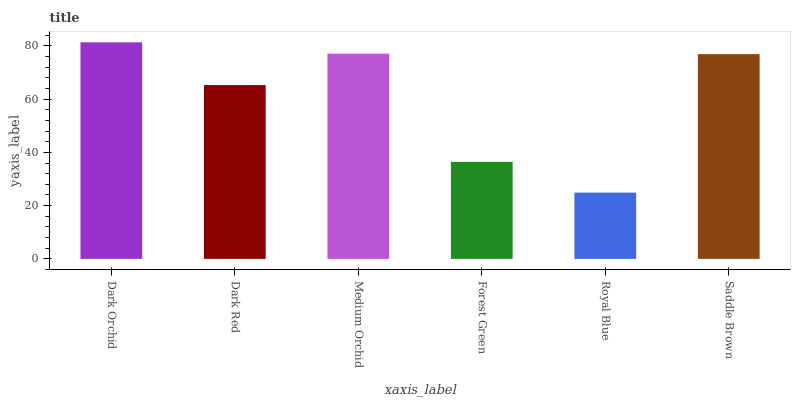Is Royal Blue the minimum?
Answer yes or no. Yes. Is Dark Orchid the maximum?
Answer yes or no. Yes. Is Dark Red the minimum?
Answer yes or no. No. Is Dark Red the maximum?
Answer yes or no. No. Is Dark Orchid greater than Dark Red?
Answer yes or no. Yes. Is Dark Red less than Dark Orchid?
Answer yes or no. Yes. Is Dark Red greater than Dark Orchid?
Answer yes or no. No. Is Dark Orchid less than Dark Red?
Answer yes or no. No. Is Saddle Brown the high median?
Answer yes or no. Yes. Is Dark Red the low median?
Answer yes or no. Yes. Is Medium Orchid the high median?
Answer yes or no. No. Is Saddle Brown the low median?
Answer yes or no. No. 